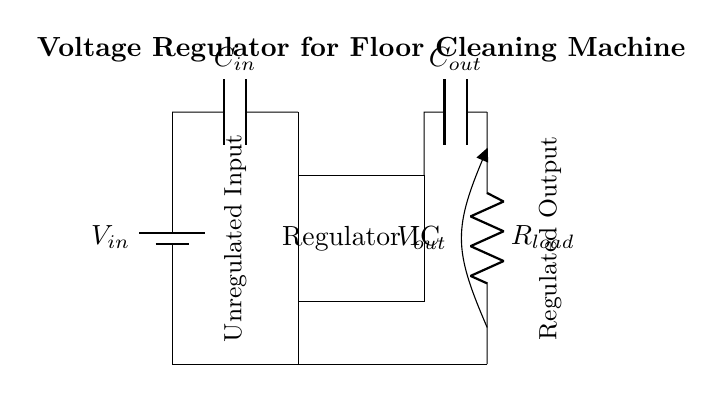What is the input component in the circuit? The input component is the battery, indicated as V_in in the diagram. It supplies the unregulated voltage to the circuit.
Answer: battery What type of component is used for filtering in this circuit? The circuit uses capacitors, specifically C_in and C_out, to filter voltages. Capacitors smooth out voltage fluctuations and provide stable power to the load.
Answer: capacitors How many output capacitors are present in the circuit? There is one output capacitor, which is labeled C_out. It connects to the output side of the regulator to stabilize the output voltage.
Answer: one What is the function of the regulator IC in this circuit? The regulator IC’s function is to maintain a stable output voltage V_out regardless of variations in the input voltage and load conditions.
Answer: stable voltage What is the load component in the circuit? The load component is represented by R_load, which simulates the device that will draw power from the regulated output voltage.
Answer: resistor How does the regulator maintain the output voltage despite changes in input voltage? The regulator adjusts the output voltage dynamically based on feedback from the load and input voltage, ensuring V_out remains constant. This self-correction is critical for reliable performance.
Answer: feedback mechanism 